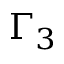<formula> <loc_0><loc_0><loc_500><loc_500>\Gamma _ { 3 }</formula> 